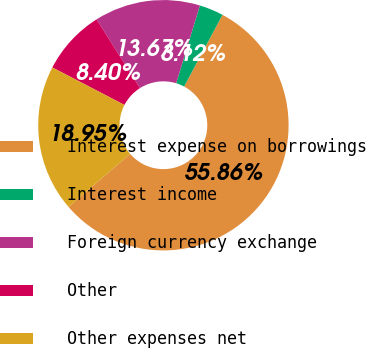<chart> <loc_0><loc_0><loc_500><loc_500><pie_chart><fcel>Interest expense on borrowings<fcel>Interest income<fcel>Foreign currency exchange<fcel>Other<fcel>Other expenses net<nl><fcel>55.86%<fcel>3.12%<fcel>13.67%<fcel>8.4%<fcel>18.95%<nl></chart> 